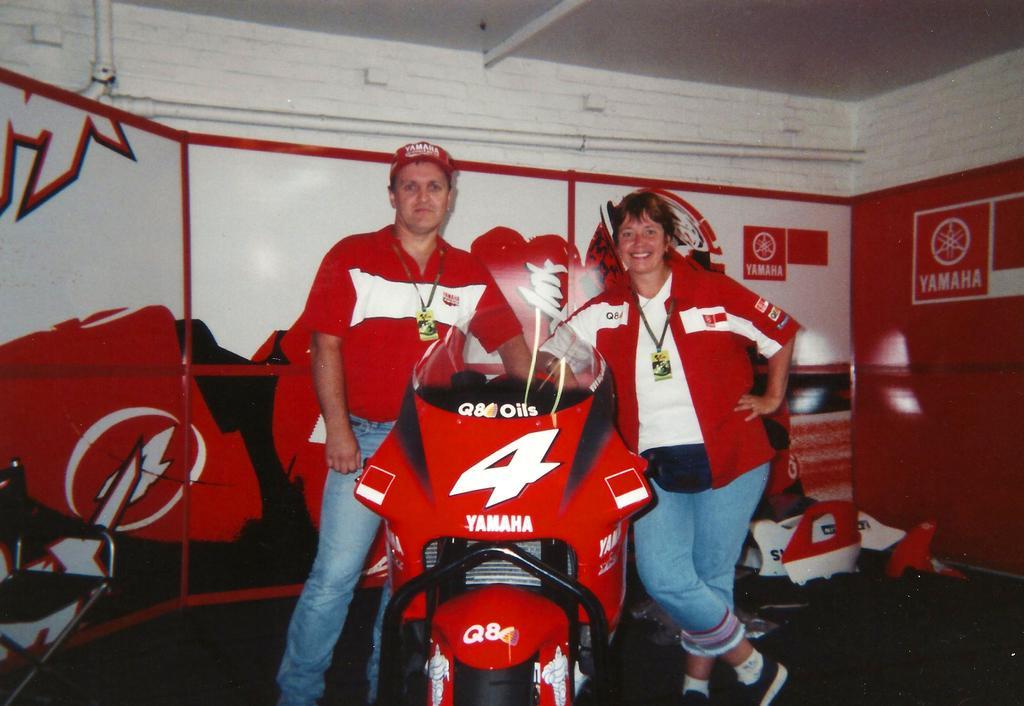Could you give a brief overview of what you see in this image? In this image I can see two persons are standing and here I can see a motorcycle. I can also see both of them are wearing red colour dress, blue jeans and here I can see colour of this motorcycle is red. I can also see YAMAHA is written at few places. 